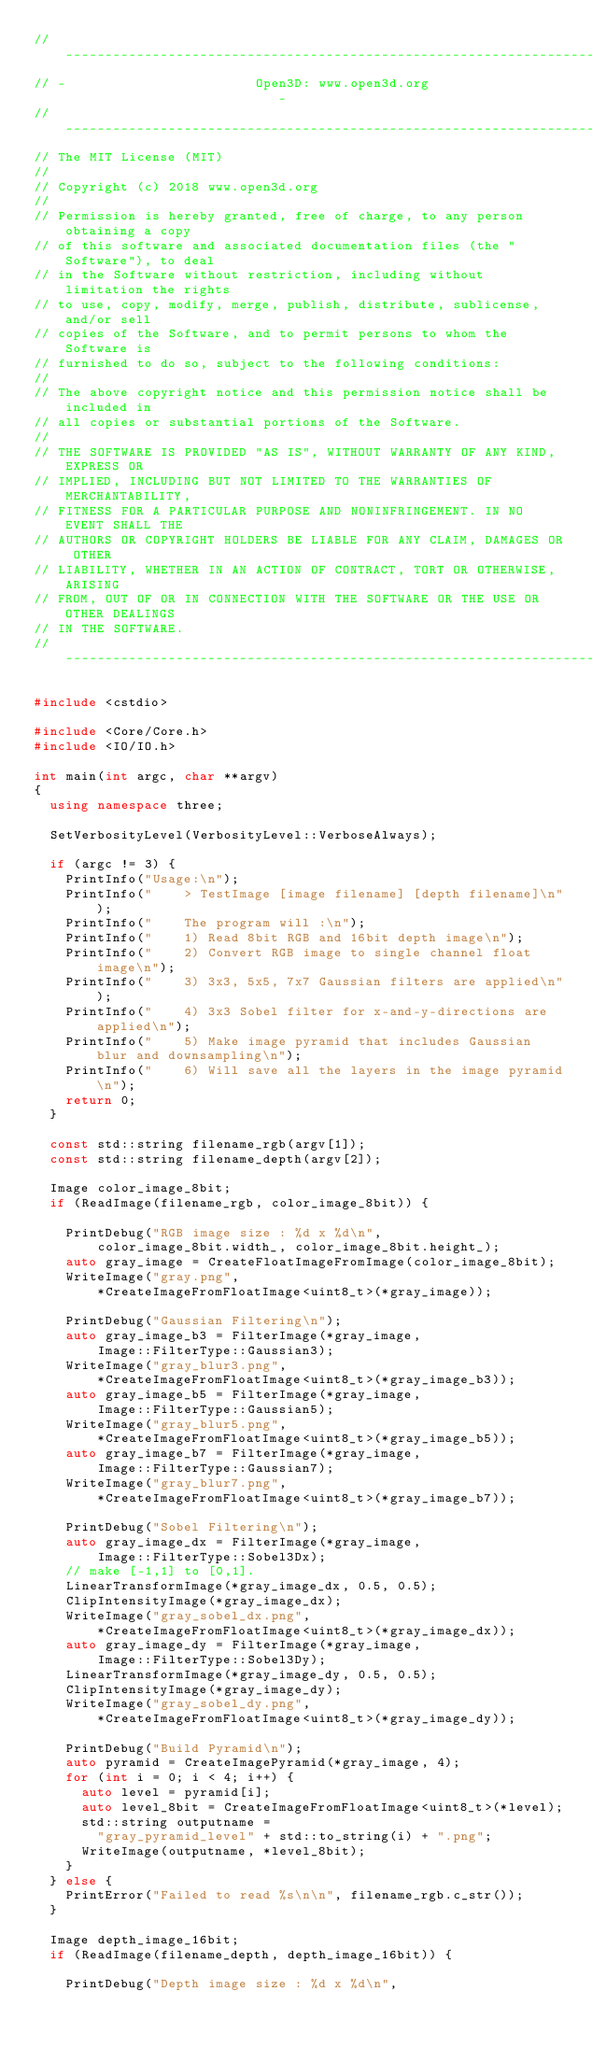Convert code to text. <code><loc_0><loc_0><loc_500><loc_500><_C++_>// ----------------------------------------------------------------------------
// -                        Open3D: www.open3d.org                            -
// ----------------------------------------------------------------------------
// The MIT License (MIT)
//
// Copyright (c) 2018 www.open3d.org
//
// Permission is hereby granted, free of charge, to any person obtaining a copy
// of this software and associated documentation files (the "Software"), to deal
// in the Software without restriction, including without limitation the rights
// to use, copy, modify, merge, publish, distribute, sublicense, and/or sell
// copies of the Software, and to permit persons to whom the Software is
// furnished to do so, subject to the following conditions:
//
// The above copyright notice and this permission notice shall be included in
// all copies or substantial portions of the Software.
//
// THE SOFTWARE IS PROVIDED "AS IS", WITHOUT WARRANTY OF ANY KIND, EXPRESS OR
// IMPLIED, INCLUDING BUT NOT LIMITED TO THE WARRANTIES OF MERCHANTABILITY,
// FITNESS FOR A PARTICULAR PURPOSE AND NONINFRINGEMENT. IN NO EVENT SHALL THE
// AUTHORS OR COPYRIGHT HOLDERS BE LIABLE FOR ANY CLAIM, DAMAGES OR OTHER
// LIABILITY, WHETHER IN AN ACTION OF CONTRACT, TORT OR OTHERWISE, ARISING
// FROM, OUT OF OR IN CONNECTION WITH THE SOFTWARE OR THE USE OR OTHER DEALINGS
// IN THE SOFTWARE.
// ----------------------------------------------------------------------------

#include <cstdio>

#include <Core/Core.h>
#include <IO/IO.h>

int main(int argc, char **argv)
{
	using namespace three;

	SetVerbosityLevel(VerbosityLevel::VerboseAlways);

	if (argc != 3) {
		PrintInfo("Usage:\n");
		PrintInfo("    > TestImage [image filename] [depth filename]\n");
		PrintInfo("    The program will :\n");
		PrintInfo("    1) Read 8bit RGB and 16bit depth image\n");
		PrintInfo("    2) Convert RGB image to single channel float image\n");
		PrintInfo("    3) 3x3, 5x5, 7x7 Gaussian filters are applied\n");
		PrintInfo("    4) 3x3 Sobel filter for x-and-y-directions are applied\n");
		PrintInfo("    5) Make image pyramid that includes Gaussian blur and downsampling\n");
		PrintInfo("    6) Will save all the layers in the image pyramid\n");
		return 0;
	}

	const std::string filename_rgb(argv[1]);
	const std::string filename_depth(argv[2]);

	Image color_image_8bit;
	if (ReadImage(filename_rgb, color_image_8bit)) {

		PrintDebug("RGB image size : %d x %d\n",
				color_image_8bit.width_, color_image_8bit.height_);
		auto gray_image = CreateFloatImageFromImage(color_image_8bit);
		WriteImage("gray.png",
				*CreateImageFromFloatImage<uint8_t>(*gray_image));

		PrintDebug("Gaussian Filtering\n");
		auto gray_image_b3 = FilterImage(*gray_image,
				Image::FilterType::Gaussian3);
		WriteImage("gray_blur3.png",
				*CreateImageFromFloatImage<uint8_t>(*gray_image_b3));
		auto gray_image_b5 = FilterImage(*gray_image,
				Image::FilterType::Gaussian5);
		WriteImage("gray_blur5.png",
				*CreateImageFromFloatImage<uint8_t>(*gray_image_b5));
		auto gray_image_b7 = FilterImage(*gray_image,
				Image::FilterType::Gaussian7);
		WriteImage("gray_blur7.png",
				*CreateImageFromFloatImage<uint8_t>(*gray_image_b7));

		PrintDebug("Sobel Filtering\n");
		auto gray_image_dx = FilterImage(*gray_image,
				Image::FilterType::Sobel3Dx);
		// make [-1,1] to [0,1].
		LinearTransformImage(*gray_image_dx, 0.5, 0.5);
		ClipIntensityImage(*gray_image_dx);
		WriteImage("gray_sobel_dx.png",
				*CreateImageFromFloatImage<uint8_t>(*gray_image_dx));
		auto gray_image_dy = FilterImage(*gray_image,
				Image::FilterType::Sobel3Dy);
		LinearTransformImage(*gray_image_dy, 0.5, 0.5);
		ClipIntensityImage(*gray_image_dy);
		WriteImage("gray_sobel_dy.png",
				*CreateImageFromFloatImage<uint8_t>(*gray_image_dy));

		PrintDebug("Build Pyramid\n");
		auto pyramid = CreateImagePyramid(*gray_image, 4);
		for (int i = 0; i < 4; i++) {
			auto level = pyramid[i];
			auto level_8bit = CreateImageFromFloatImage<uint8_t>(*level);
			std::string outputname =
				"gray_pyramid_level" + std::to_string(i) + ".png";
			WriteImage(outputname, *level_8bit);
		}
	} else {
		PrintError("Failed to read %s\n\n", filename_rgb.c_str());
	}

	Image depth_image_16bit;
	if (ReadImage(filename_depth, depth_image_16bit)) {

		PrintDebug("Depth image size : %d x %d\n",</code> 